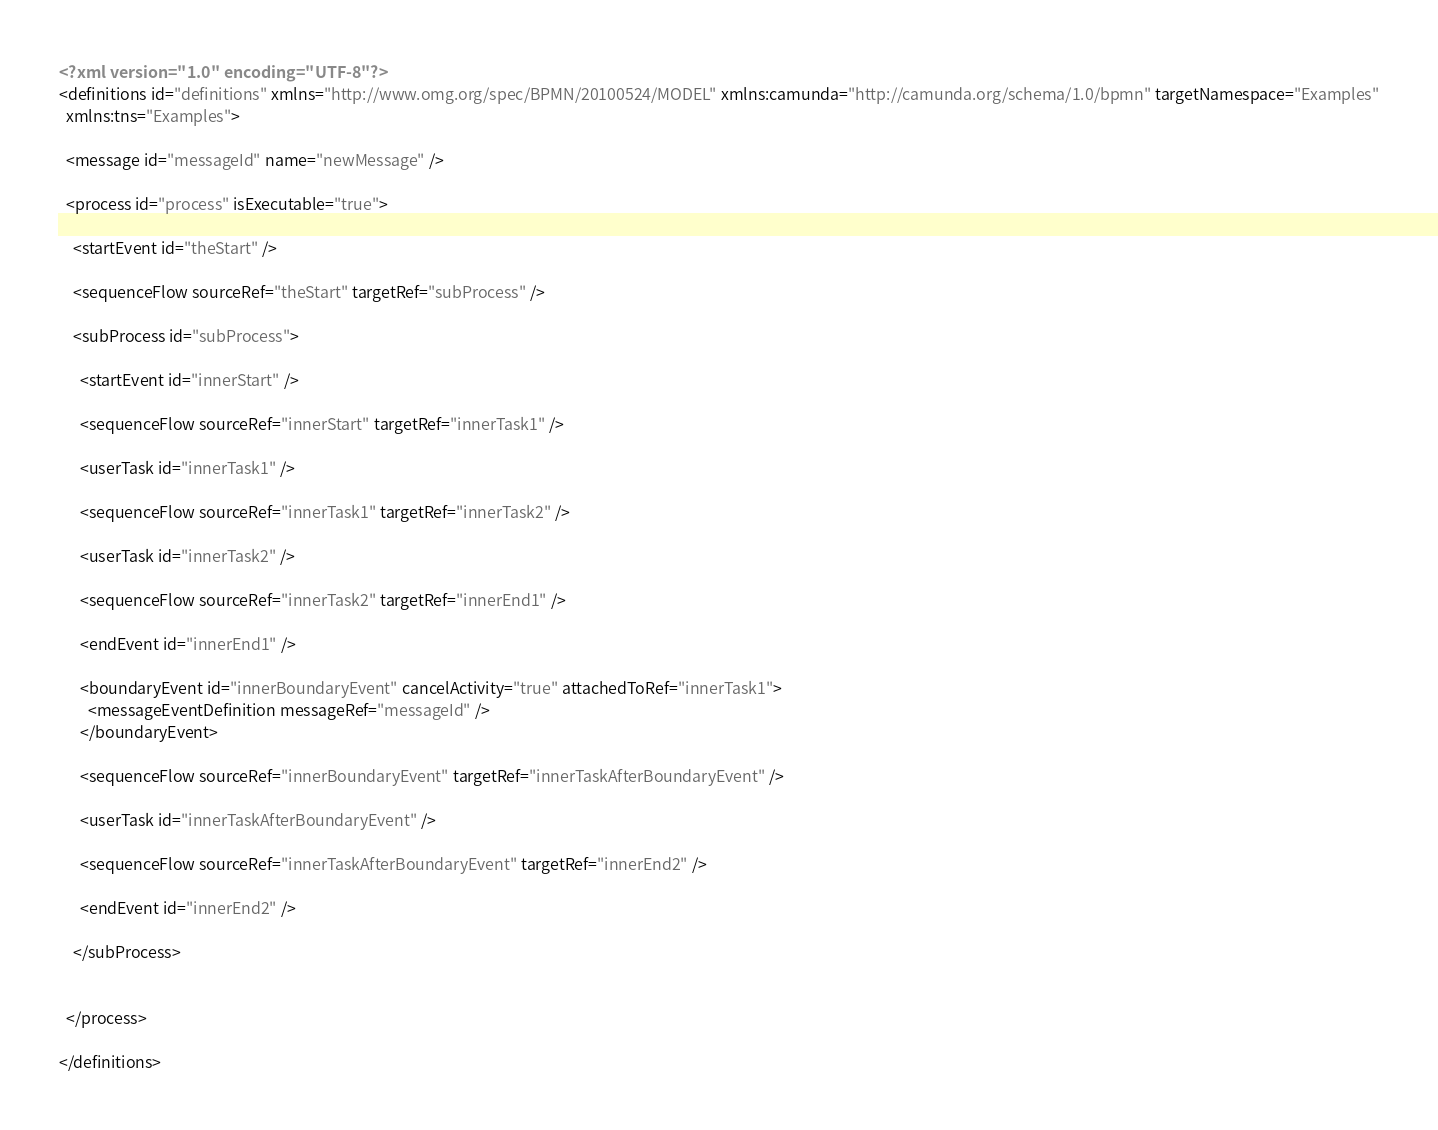Convert code to text. <code><loc_0><loc_0><loc_500><loc_500><_XML_><?xml version="1.0" encoding="UTF-8"?>
<definitions id="definitions" xmlns="http://www.omg.org/spec/BPMN/20100524/MODEL" xmlns:camunda="http://camunda.org/schema/1.0/bpmn" targetNamespace="Examples"
  xmlns:tns="Examples">

  <message id="messageId" name="newMessage" />

  <process id="process" isExecutable="true">

    <startEvent id="theStart" />

    <sequenceFlow sourceRef="theStart" targetRef="subProcess" />

    <subProcess id="subProcess">

      <startEvent id="innerStart" />

      <sequenceFlow sourceRef="innerStart" targetRef="innerTask1" />

      <userTask id="innerTask1" />

      <sequenceFlow sourceRef="innerTask1" targetRef="innerTask2" />

      <userTask id="innerTask2" />

      <sequenceFlow sourceRef="innerTask2" targetRef="innerEnd1" />

      <endEvent id="innerEnd1" />

      <boundaryEvent id="innerBoundaryEvent" cancelActivity="true" attachedToRef="innerTask1">
        <messageEventDefinition messageRef="messageId" />
      </boundaryEvent>

      <sequenceFlow sourceRef="innerBoundaryEvent" targetRef="innerTaskAfterBoundaryEvent" />

      <userTask id="innerTaskAfterBoundaryEvent" />

      <sequenceFlow sourceRef="innerTaskAfterBoundaryEvent" targetRef="innerEnd2" />

      <endEvent id="innerEnd2" />

    </subProcess>


  </process>

</definitions></code> 